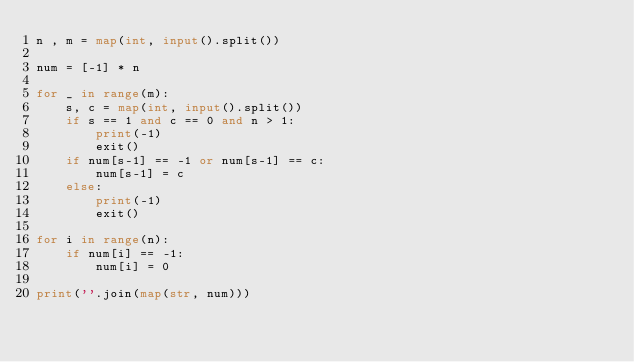<code> <loc_0><loc_0><loc_500><loc_500><_Python_>n , m = map(int, input().split())

num = [-1] * n

for _ in range(m):
    s, c = map(int, input().split())
    if s == 1 and c == 0 and n > 1:
        print(-1)
        exit()
    if num[s-1] == -1 or num[s-1] == c:
        num[s-1] = c
    else:
        print(-1)
        exit()

for i in range(n):
    if num[i] == -1:
        num[i] = 0

print(''.join(map(str, num)))

</code> 